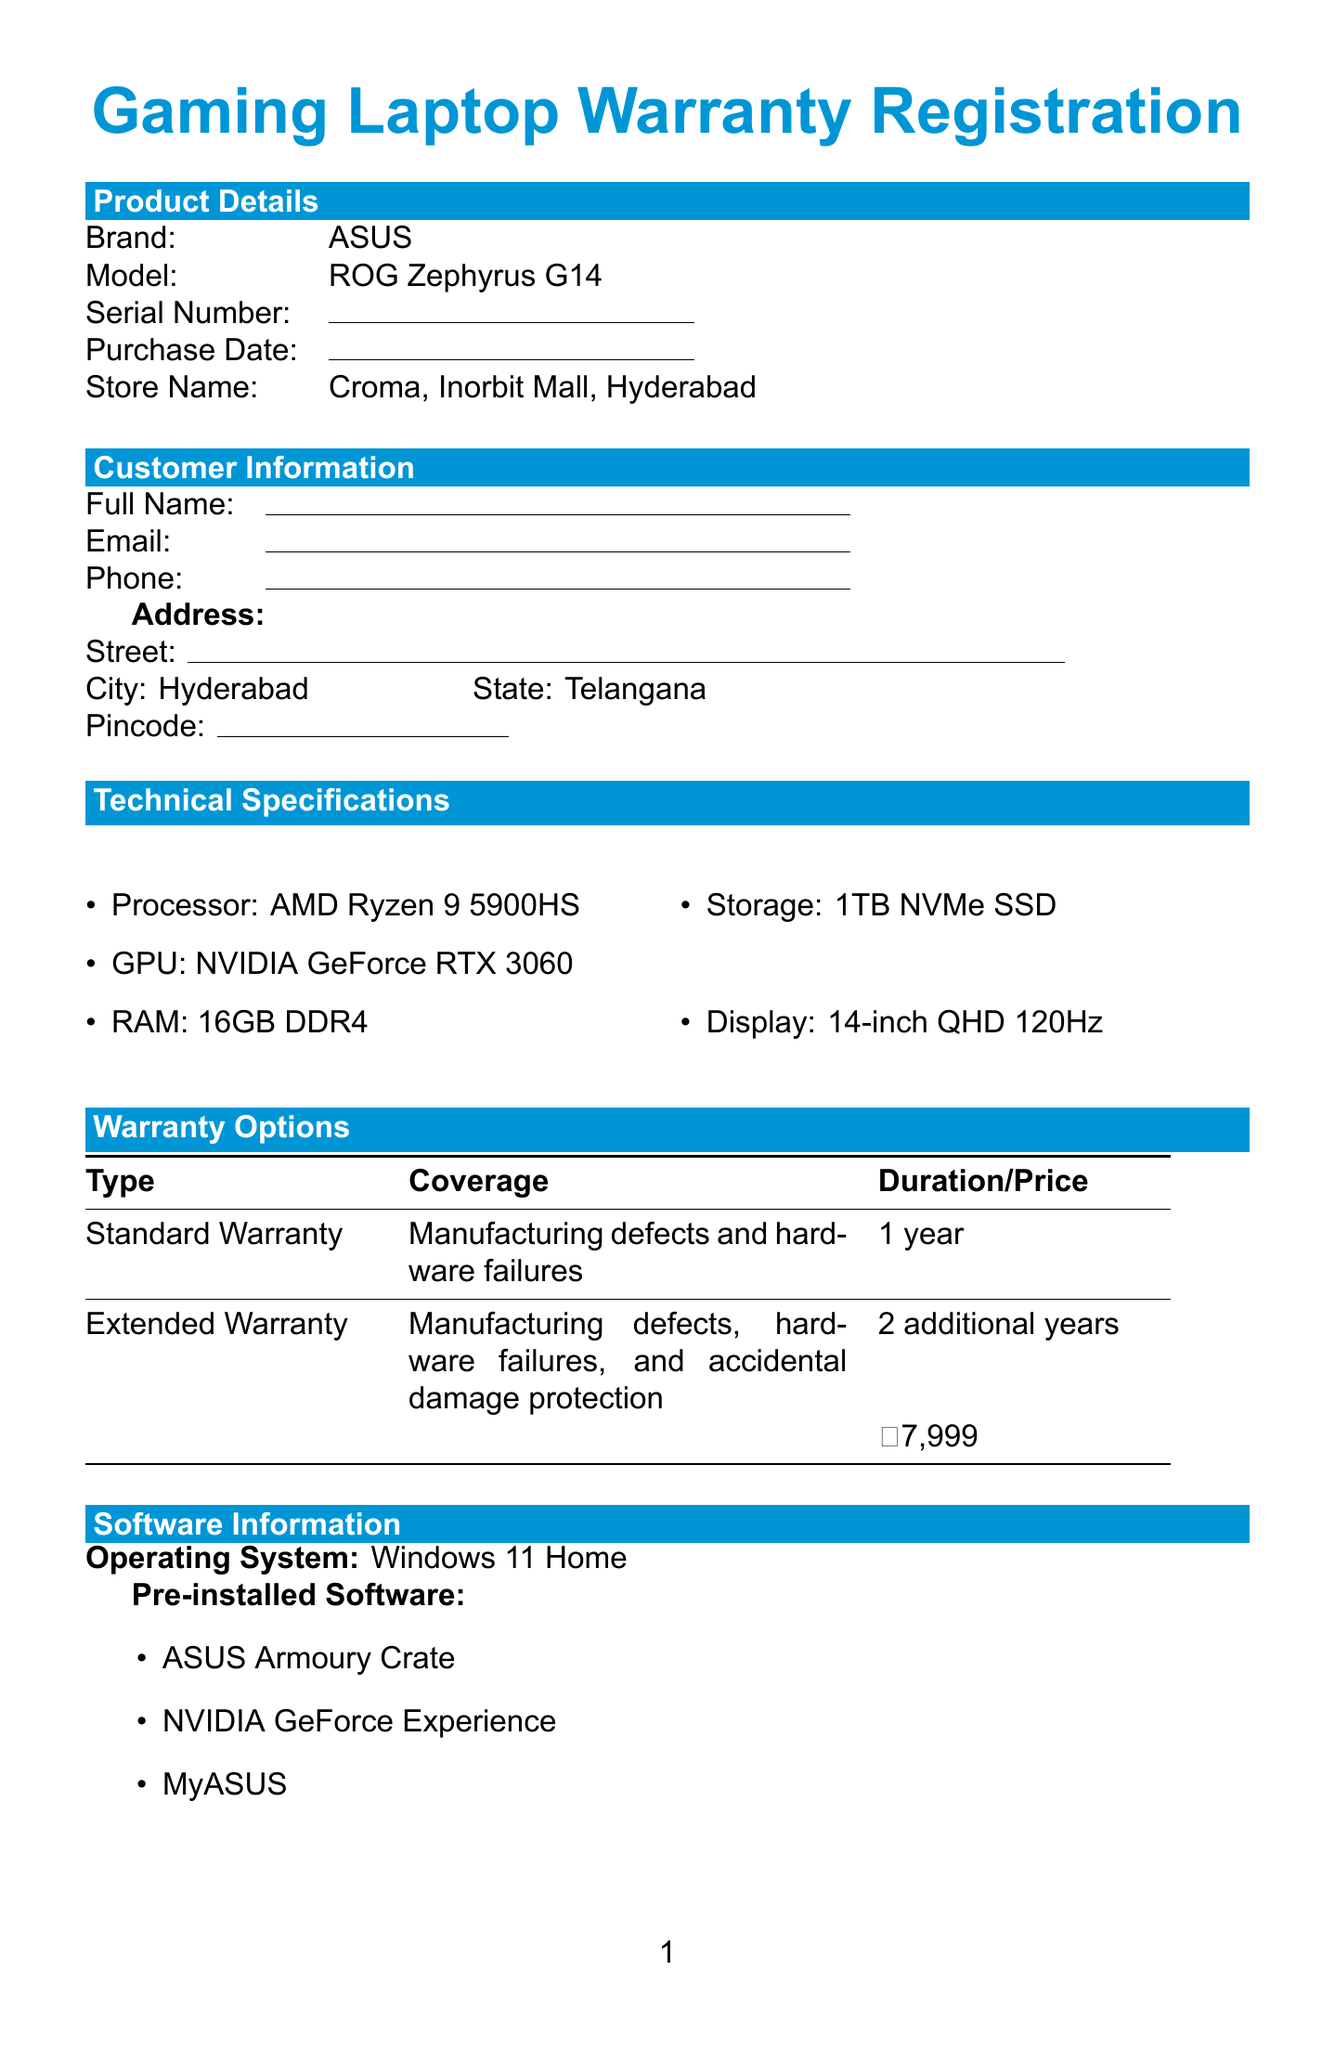What is the brand of the laptop? The brand is explicitly stated in the product details section of the document as ASUS.
Answer: ASUS What is the model of the gaming laptop? The model name is provided in the product details section, which is ROG Zephyrus G14.
Answer: ROG Zephyrus G14 What is the duration of the standard warranty? The duration for the standard warranty is specified in the warranty options section as 1 year.
Answer: 1 year What is the price of the extended warranty? The price for the extended warranty is mentioned in the warranty options section as ₹7,999.
Answer: ₹7,999 Where was the laptop purchased? It is found in the product details section that the store name is Croma, Inorbit Mall, Hyderabad.
Answer: Croma, Inorbit Mall, Hyderabad What additional service costs ₹4,999? The additional service listed for this price in the document is the data recovery service.
Answer: Data recovery service What is the customer responsible for before any warranty service? The document states that the customer is responsible for backing up their data before any warranty service.
Answer: Backing up their data What is the email for customer support? The email address for support is provided in the support information section as support_india@asus.com.
Answer: support_india@asus.com Which operating system comes pre-installed on the laptop? The operating system listed in the software information section is Windows 11 Home.
Answer: Windows 11 Home 